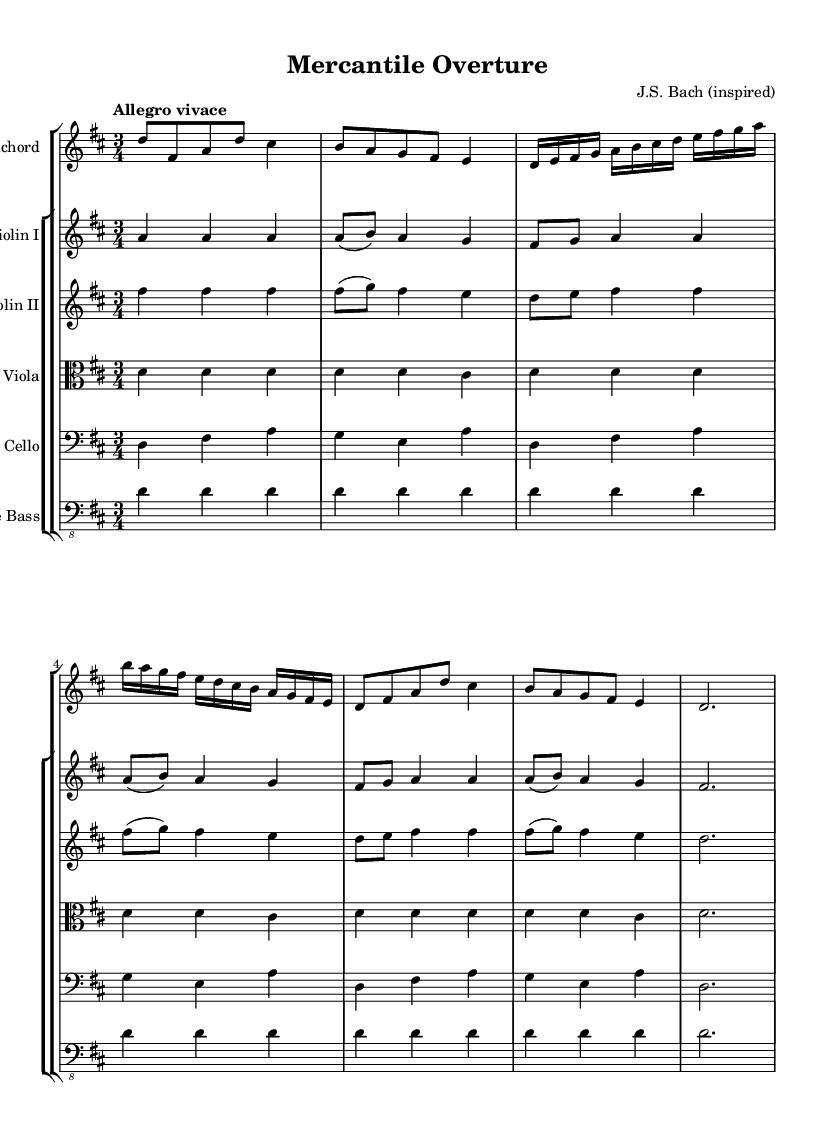What is the key signature of this music? The key signature has two sharps, indicating it is in D major. A key signature with two sharps means F# and C# are present, which corresponds to D major.
Answer: D major What is the time signature of this music? The time signature is indicated by the fraction at the beginning of the sheet music, showing three beats per measure. The "3/4" means there are three beats (the numerator) in each measure and each beat is a quarter note (the denominator).
Answer: 3/4 What is the tempo marking of this music? The tempo marking is "Allegro vivace," which indicates a fast and lively pace for the performance. Allegro generally means fast, and vivace adds an extra connotation of vivacity or liveliness.
Answer: Allegro vivace What is the primary instrument featured in this concerto? The primary instrument can be identified at the top of the staff where it states "Harpsichord," indicating that this is the main instrument for this piece.
Answer: Harpsichord How many parts are in the string ensemble displayed? The score contains five distinct string parts, which include two violins, a viola, a cello, and a double bass, all contributing to the harmonic and melodic texture of the piece.
Answer: Five What is the rhythmic pattern established in the harpsichord's first section? The first section is characterized by a combination of eighth notes followed by quarter notes, creating a bouncing and lively rhythmic pattern typical of Baroque music. Analyzing the notes reveals repetitive and syncopated sequences that drive the rhythm forward.
Answer: Eighth and quarter notes What is the texture of the music based on the instrumentation? The texture can be described as polyphonic since multiple independent melodies are interwoven amongst the different instruments, which is a hallmark of Baroque music. Each part has its own melodic line that complements the others, creating a rich tapestry of sound.
Answer: Polyphonic 